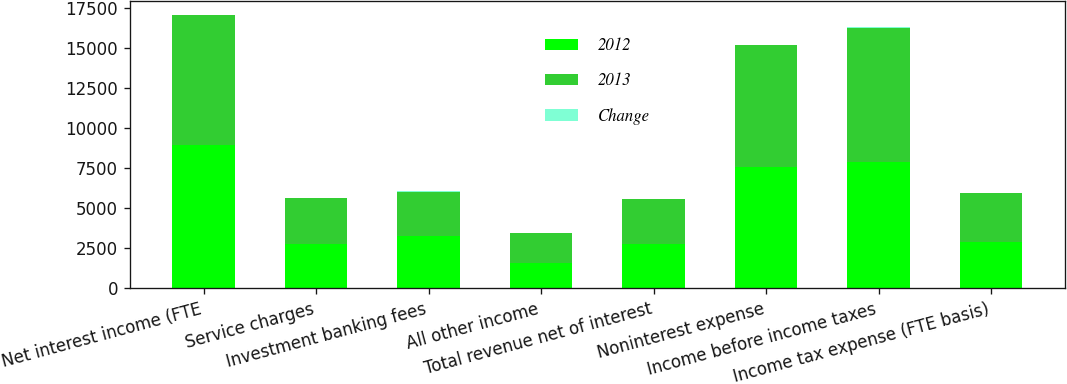<chart> <loc_0><loc_0><loc_500><loc_500><stacked_bar_chart><ecel><fcel>Net interest income (FTE<fcel>Service charges<fcel>Investment banking fees<fcel>All other income<fcel>Total revenue net of interest<fcel>Noninterest expense<fcel>Income before income taxes<fcel>Income tax expense (FTE basis)<nl><fcel>2012<fcel>8914<fcel>2787<fcel>3235<fcel>1545<fcel>2790<fcel>7552<fcel>7854<fcel>2880<nl><fcel>2013<fcel>8135<fcel>2867<fcel>2793<fcel>1879<fcel>2790<fcel>7619<fcel>8397<fcel>3053<nl><fcel>Change<fcel>10<fcel>3<fcel>16<fcel>18<fcel>5<fcel>1<fcel>6<fcel>6<nl></chart> 